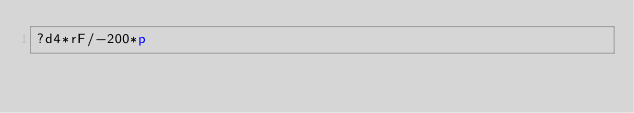<code> <loc_0><loc_0><loc_500><loc_500><_dc_>?d4*rF/-200*p</code> 